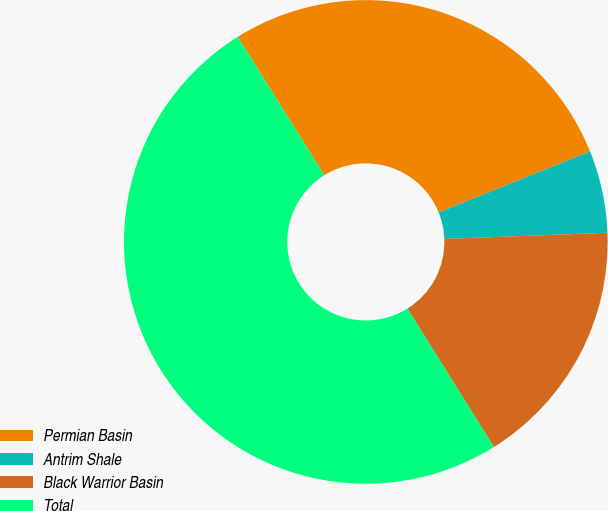Convert chart. <chart><loc_0><loc_0><loc_500><loc_500><pie_chart><fcel>Permian Basin<fcel>Antrim Shale<fcel>Black Warrior Basin<fcel>Total<nl><fcel>27.78%<fcel>5.5%<fcel>16.72%<fcel>50.0%<nl></chart> 